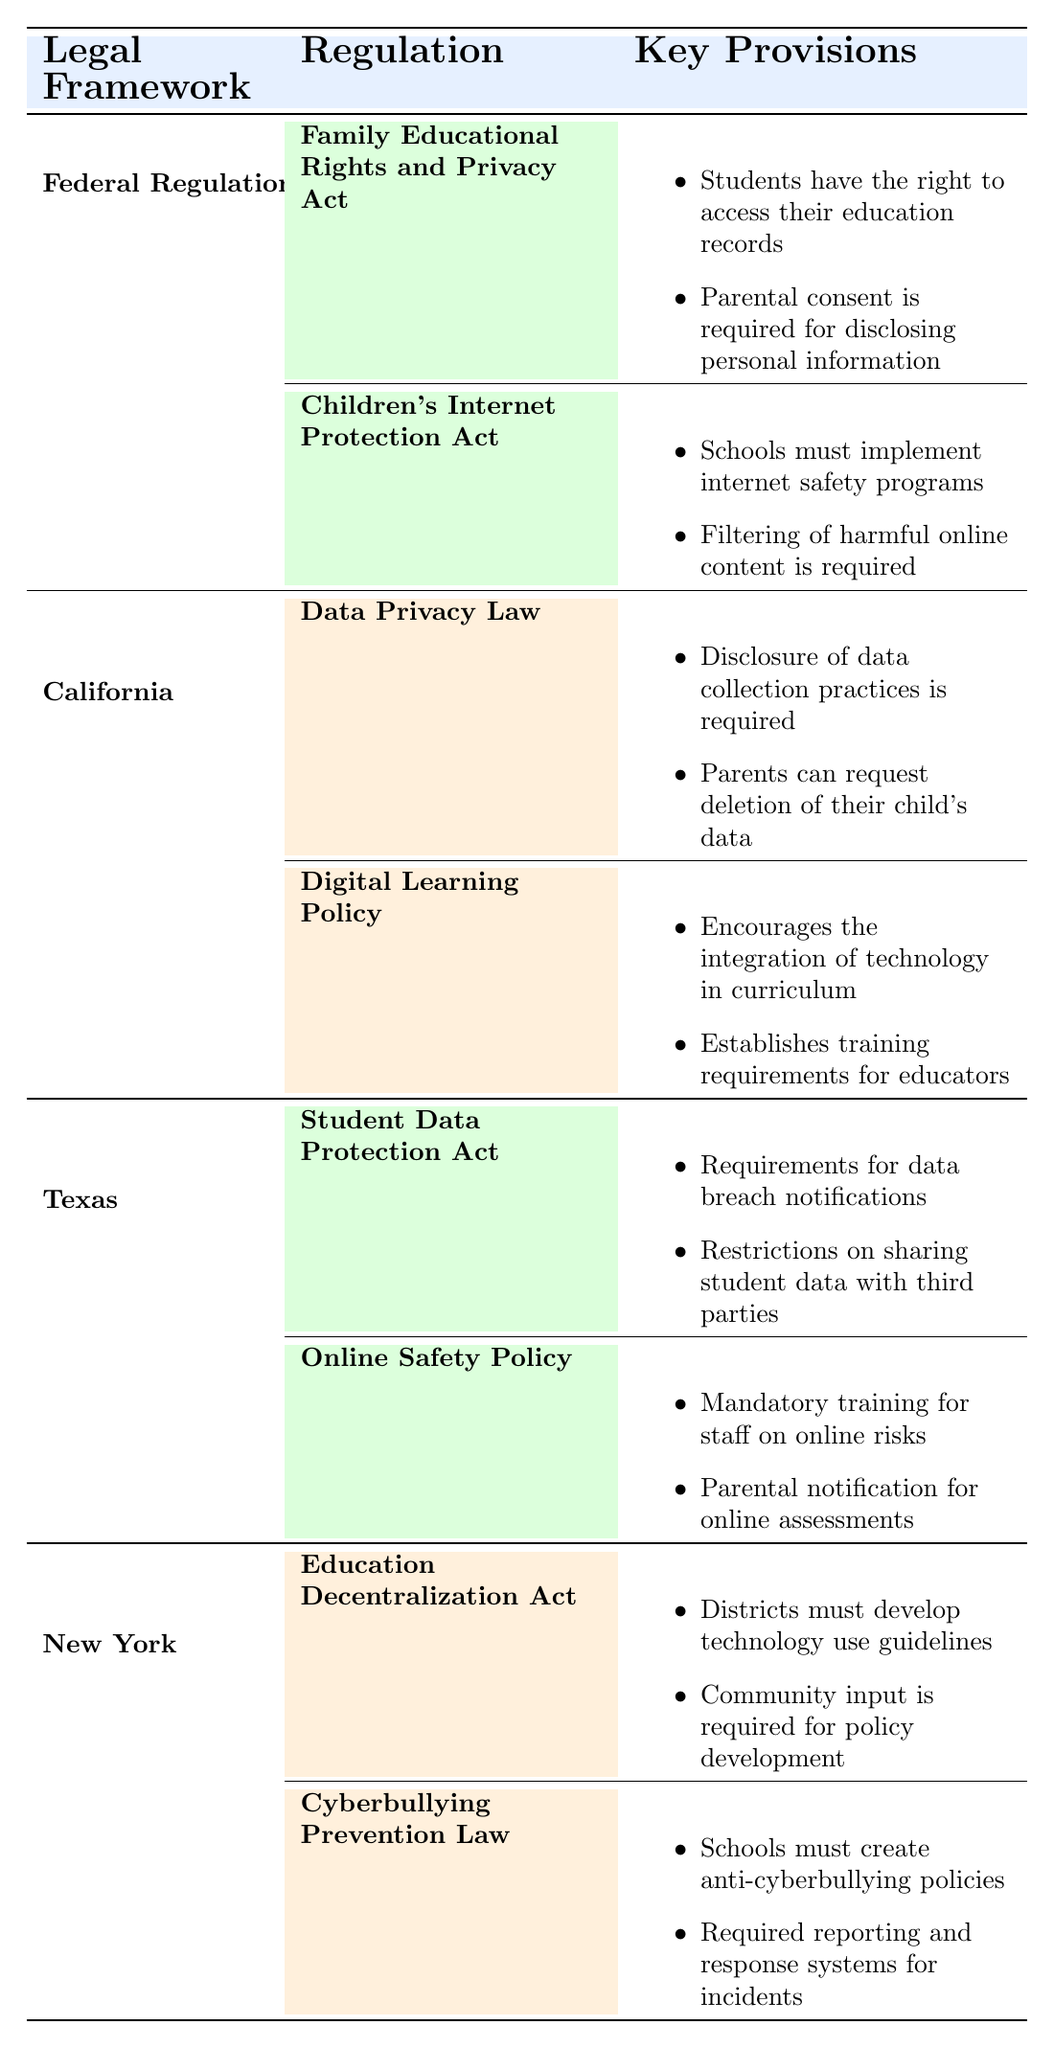What is the purpose of the Family Educational Rights and Privacy Act? The Family Educational Rights and Privacy Act is designed to protect the privacy of student education records. This is stated directly in the table under its description.
Answer: Protects the privacy of student education records Which regulation requires schools to implement internet safety programs? The regulation that requires schools to implement internet safety programs is the Children's Internet Protection Act, as identified in the table.
Answer: Children's Internet Protection Act True or False: California has a regulation regarding the protection of student data. Yes, California has the Data Privacy Law, which enhances student data privacy protections according to the table.
Answer: True What are the key provisions of the Online Safety Policy in Texas? The key provisions of the Online Safety Policy include mandatory training for staff on online risks and parental notification for online assessments, both of which are listed in the table.
Answer: Mandatory training for staff on online risks, parental notification for online assessments How many states are affected by the Family Educational Rights and Privacy Act? The table indicates that the Family Educational Rights and Privacy Act affects "All States." Therefore, the total number is all 50 states.
Answer: All States 